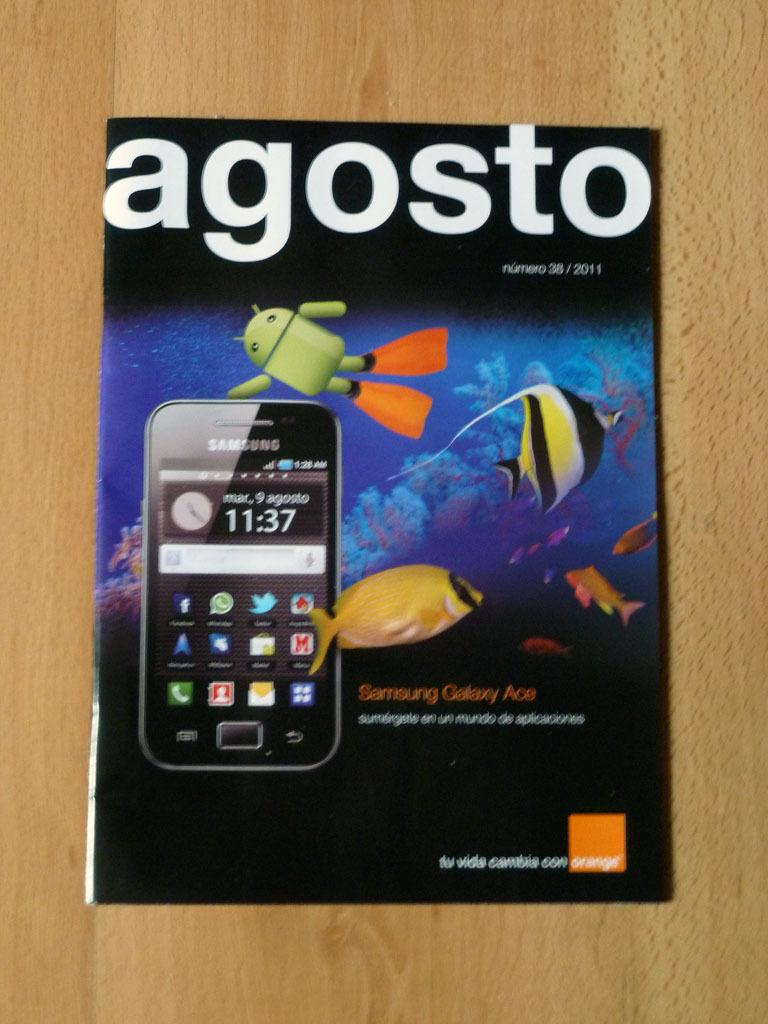Provide a one-sentence caption for the provided image. Book that is titled "Agosto" on top of a wooden table. 